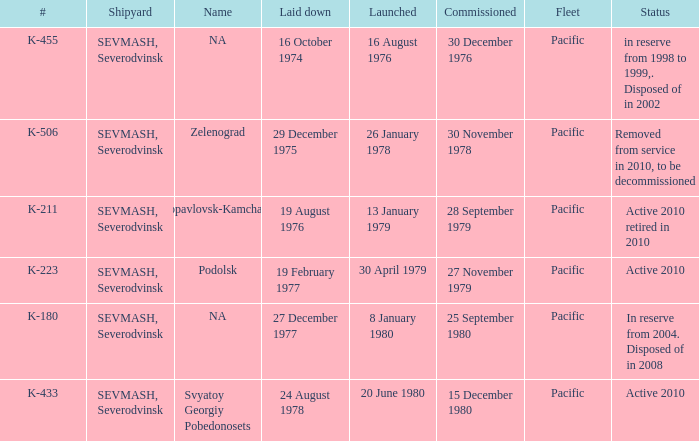What is the status of vessel number K-223? Active 2010. Help me parse the entirety of this table. {'header': ['#', 'Shipyard', 'Name', 'Laid down', 'Launched', 'Commissioned', 'Fleet', 'Status'], 'rows': [['K-455', 'SEVMASH, Severodvinsk', 'NA', '16 October 1974', '16 August 1976', '30 December 1976', 'Pacific', 'in reserve from 1998 to 1999,. Disposed of in 2002'], ['K-506', 'SEVMASH, Severodvinsk', 'Zelenograd', '29 December 1975', '26 January 1978', '30 November 1978', 'Pacific', 'Removed from service in 2010, to be decommissioned'], ['K-211', 'SEVMASH, Severodvinsk', 'Petropavlovsk-Kamchatskiy', '19 August 1976', '13 January 1979', '28 September 1979', 'Pacific', 'Active 2010 retired in 2010'], ['K-223', 'SEVMASH, Severodvinsk', 'Podolsk', '19 February 1977', '30 April 1979', '27 November 1979', 'Pacific', 'Active 2010'], ['K-180', 'SEVMASH, Severodvinsk', 'NA', '27 December 1977', '8 January 1980', '25 September 1980', 'Pacific', 'In reserve from 2004. Disposed of in 2008'], ['K-433', 'SEVMASH, Severodvinsk', 'Svyatoy Georgiy Pobedonosets', '24 August 1978', '20 June 1980', '15 December 1980', 'Pacific', 'Active 2010']]} 